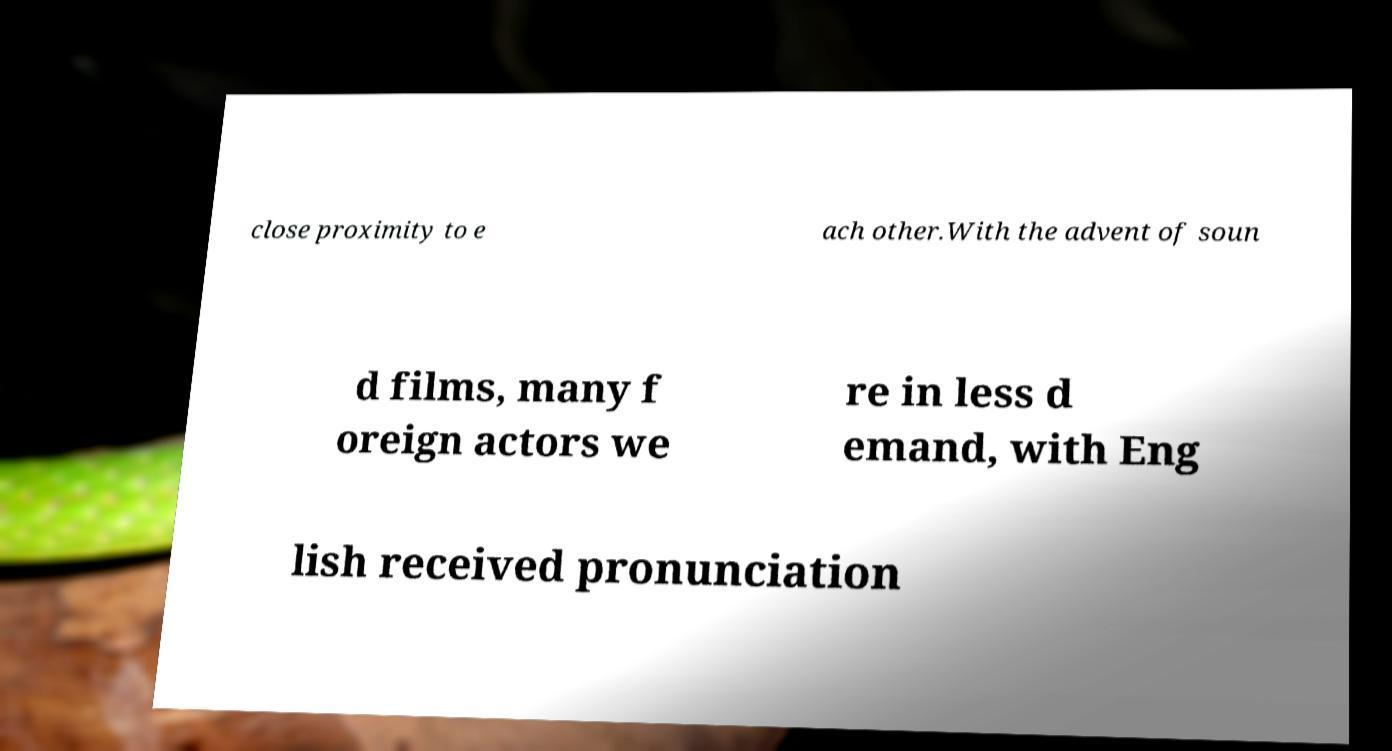Please identify and transcribe the text found in this image. close proximity to e ach other.With the advent of soun d films, many f oreign actors we re in less d emand, with Eng lish received pronunciation 